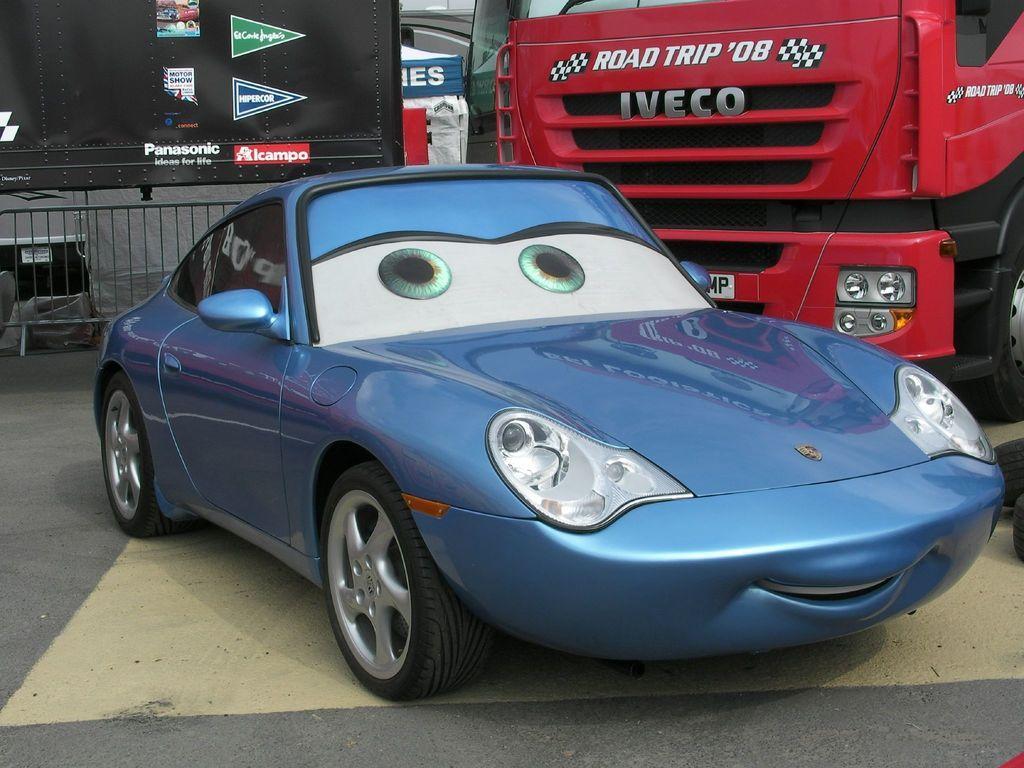Describe this image in one or two sentences. In this image I can see few vehicles. To the left I can see the railing. In the background I can see the board and few objects. 